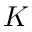<formula> <loc_0><loc_0><loc_500><loc_500>K</formula> 